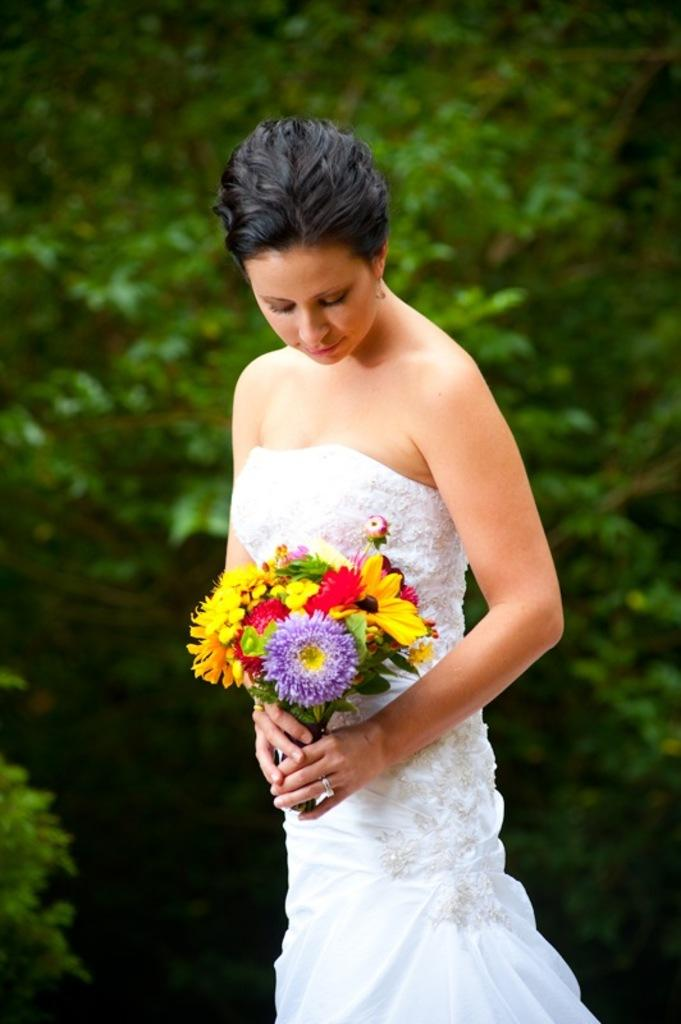Who is the main subject in the image? There is a lady in the image. What is the lady holding in the image? The lady is holding flowers. What can be seen in the background of the image? There are trees in the background of the image. What type of humor can be seen in the lady's expression in the image? There is no indication of the lady's expression in the image, so it is not possible to determine if there is any humor present. 